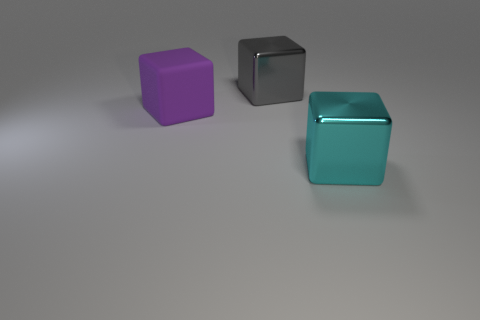Add 2 small green metal blocks. How many objects exist? 5 Subtract all metallic cubes. How many cubes are left? 1 Subtract 2 cubes. How many cubes are left? 1 Subtract all cyan blocks. Subtract all blue cylinders. How many blocks are left? 2 Subtract all big purple objects. Subtract all large blue rubber cylinders. How many objects are left? 2 Add 2 gray things. How many gray things are left? 3 Add 3 large gray metallic blocks. How many large gray metallic blocks exist? 4 Subtract 0 green blocks. How many objects are left? 3 